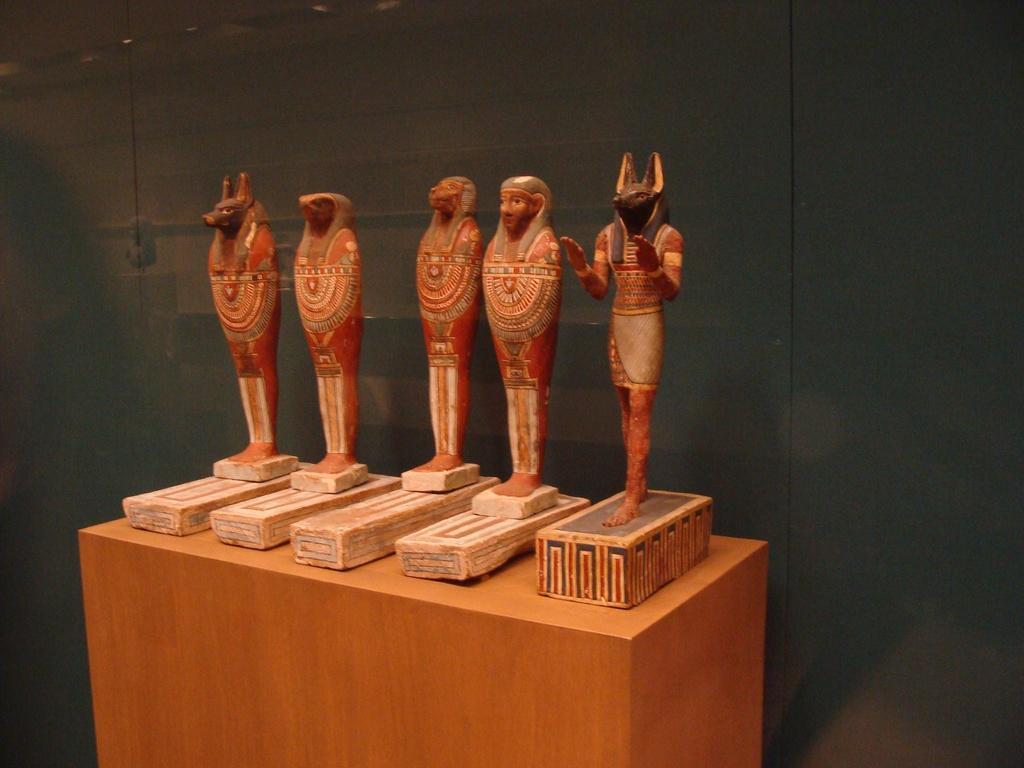What is the main object in the center of the image? There is a table in the center of the image. What is placed on the table? There are boxes on the table. What decorative items are on the boxes? There are sculptures on the boxes. What can be seen in the background of the image? There is a wall in the background of the image. How many knots are tied on the sculptures in the image? There are no knots present on the sculptures in the image. What type of tub is visible in the image? There is no tub present in the image. 